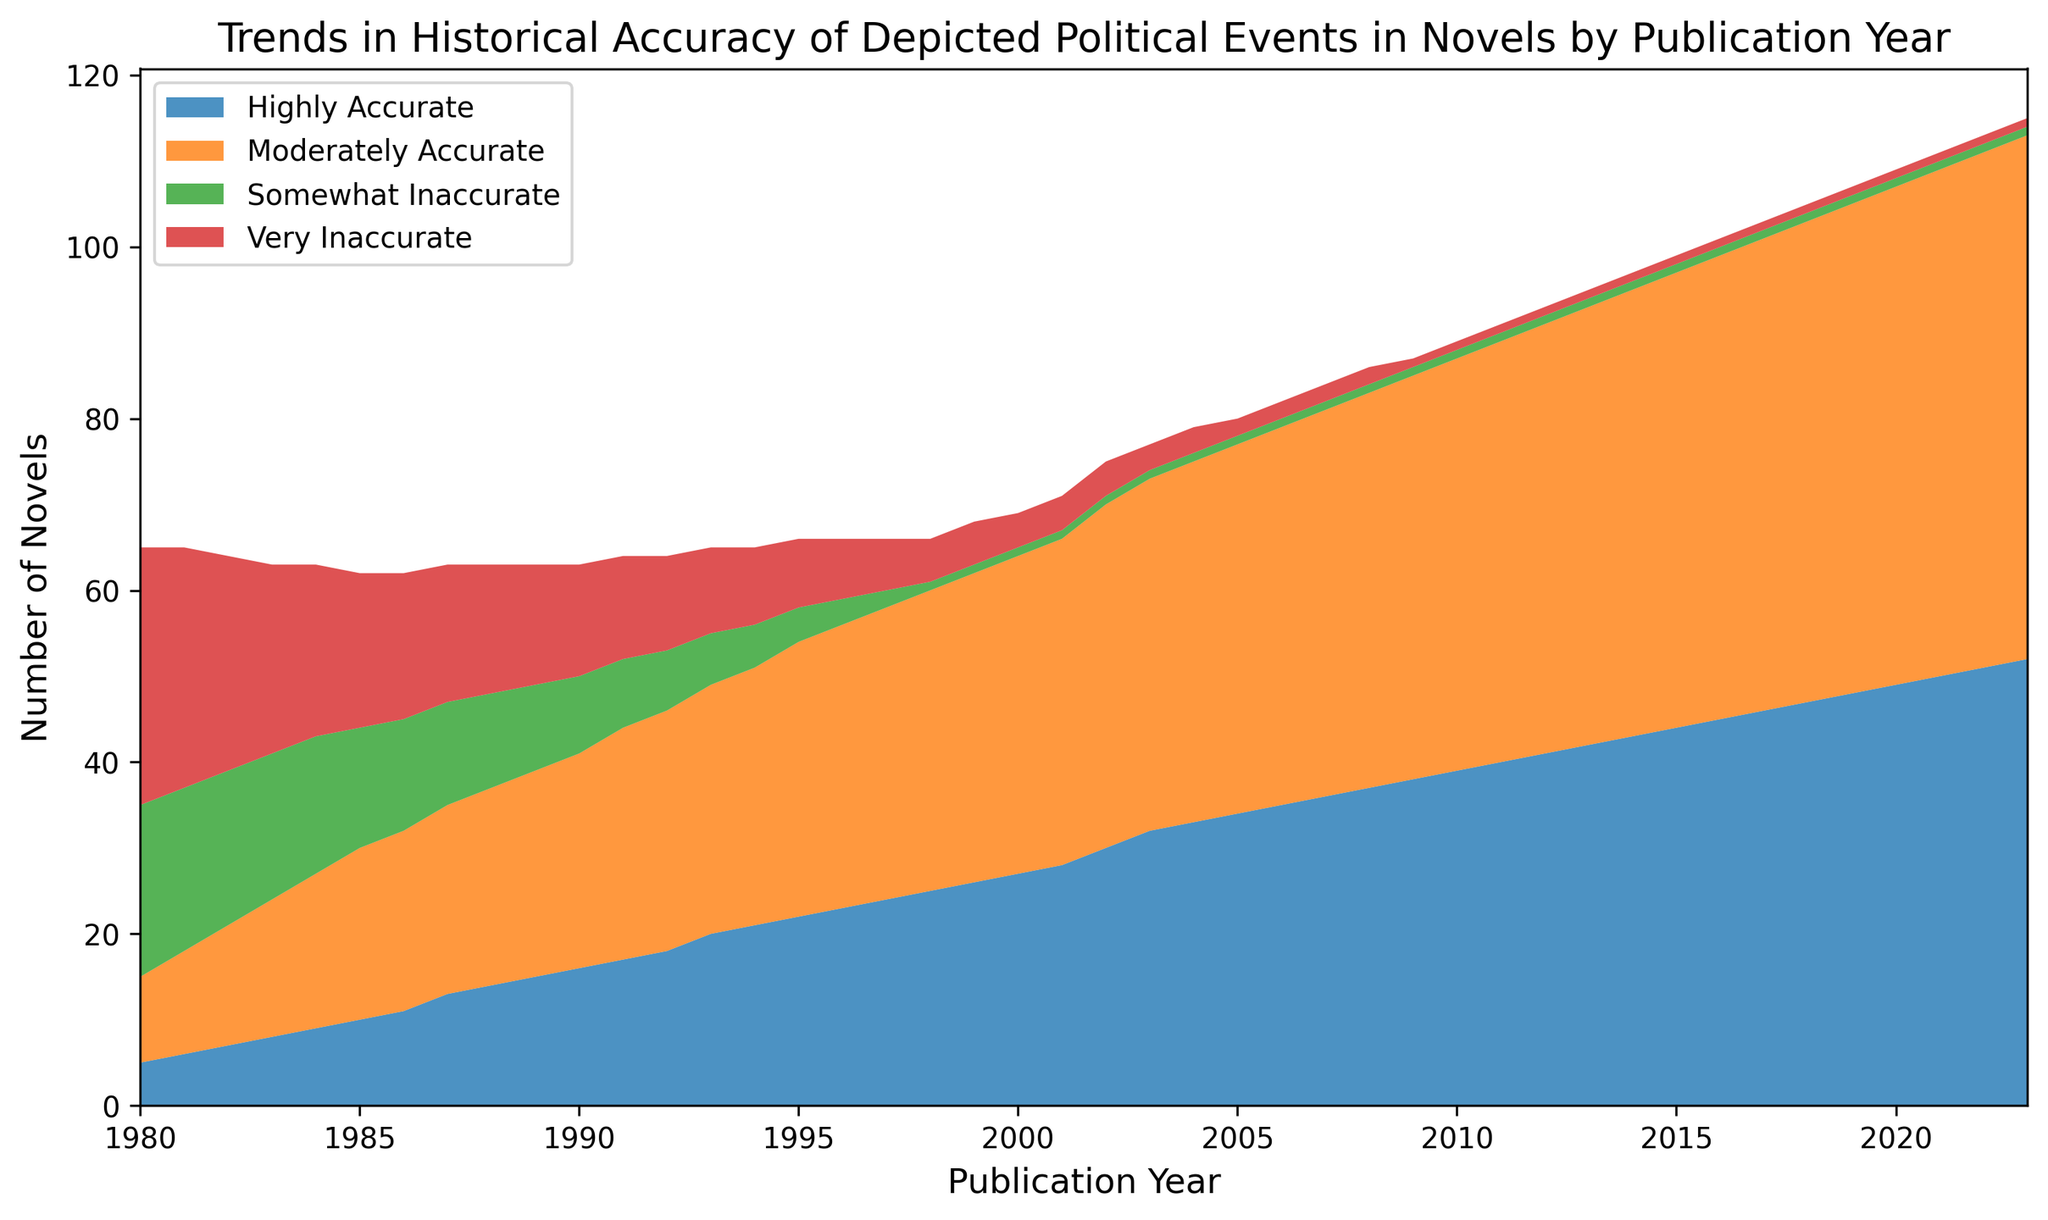Which category shows the most significant increase from 1980 to 2023? By visually analyzing the chart, we can see that the category "Highly Accurate" shows the most substantial upward trend among all categories, starting from 5 in 1980 and reaching 52 in 2023.
Answer: Highly Accurate During which year are there as many "Moderately Accurate" novels as "Highly Accurate" novels? Inspecting the plotted areas, the year 1991 shows that both "Highly Accurate" and "Moderately Accurate" categories align closely at counts of 17 and 27 respectively, though this could be a visual estimation, there might be slight variations, exact figures verify this alignment point.
Answer: 1991 What is the general trend of "Very Inaccurate" novels over the period covered in the graph? Observing the height and color of the "Very Inaccurate" section, there is a notable decline from 30 in 1980 to only 1 in the later years post-2009.
Answer: Declining By how much did the "Somewhat Inaccurate" category drop from its peak point to its lowest point? The "Somewhat Inaccurate" category peaks at 20 in 1980 and drops to 1 from 1998 onwards. Thus, the drop is 20 - 1 = 19.
Answer: 19 Which categories exhibit a positive trend over the publication years and which categories exhibit a negative trend? Visually, "Highly Accurate" and "Moderately Accurate" categories continually increase over the years. Both "Somewhat Inaccurate" and "Very Inaccurate" categories show a declining trend.
Answer: Highly Accurate and Moderately Accurate; Somewhat Inaccurate and Very Inaccurate Which two subsequent years show the sharpest drop in the "Very Inaccurate" category? By observing the decreasing area for "Very Inaccurate", 1983 to 1984 shows the sharpest decline from 22 to 20.
Answer: 1983 to 1984 In what year does the "Highly Accurate" category surpass 30 novels for the first time? Observing the "Highly Accurate" area segment, it crosses the 30-novel count in 2003.
Answer: 2003 How does the count of "Moderately Accurate" novels published in 2000 compare to the count published in 2005? From the graph, the "Moderately Accurate" category increases from 37 novels in 2000 to 43 novels in 2005.
Answer: Increases Which category has the smallest variance over the years? "Somewhat Inaccurate" maintains a small range of variation, especially compared to others, falling and stabilizing at around 1 novel over many years after its initial decline.
Answer: Somewhat Inaccurate What is the overall trend by the representation of "Highly Accurate" and "Very Inaccurate" novels over the years? "Highly Accurate" novels show a substantial increasing trend while "Very Inaccurate" significantly decreases, demonstrating overall improvement in historical accuracy in novels.
Answer: Increasing; Decreasing 